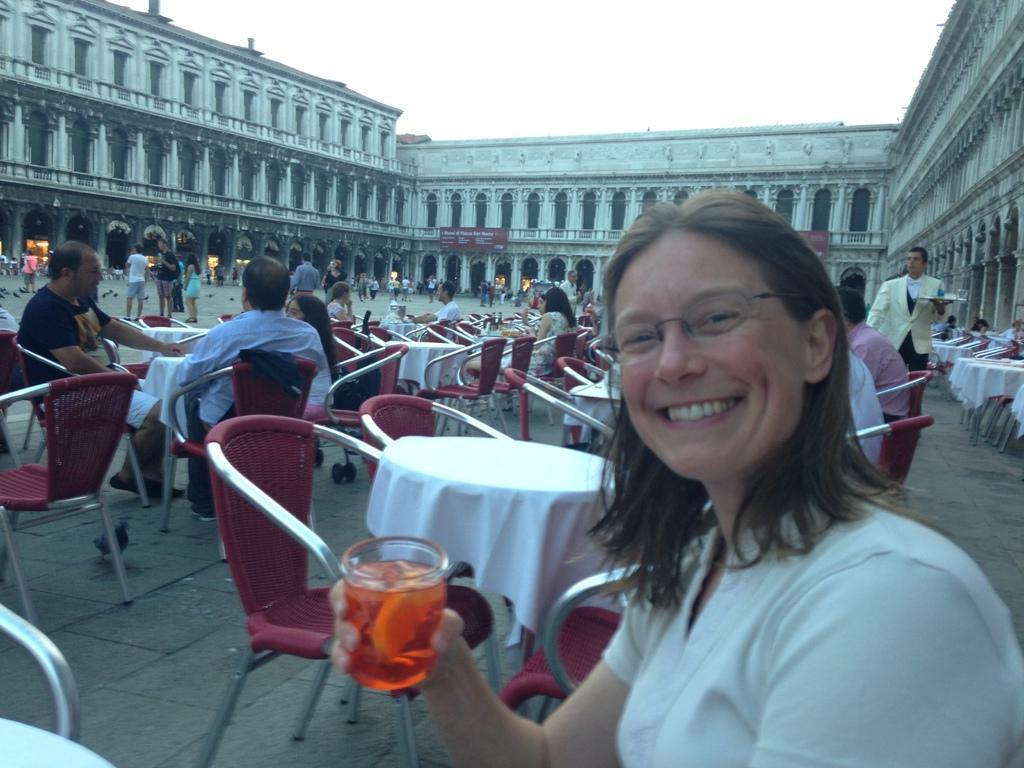Could you give a brief overview of what you see in this image? In This picture i could see many people walking around and sitting on the chairs in the back ground i could see a wall with beautiful arches. A woman in foreground giving a smile holding a glass of juice. 